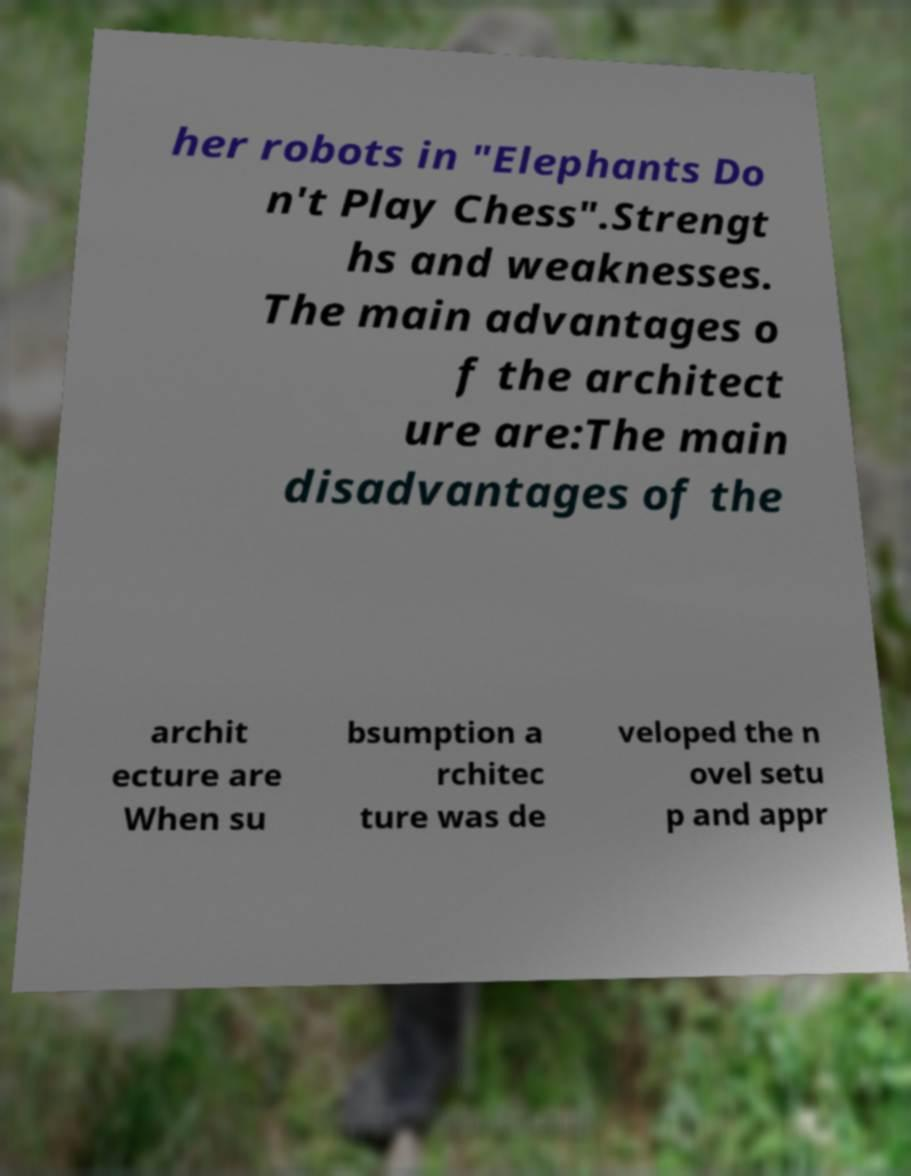There's text embedded in this image that I need extracted. Can you transcribe it verbatim? her robots in "Elephants Do n't Play Chess".Strengt hs and weaknesses. The main advantages o f the architect ure are:The main disadvantages of the archit ecture are When su bsumption a rchitec ture was de veloped the n ovel setu p and appr 